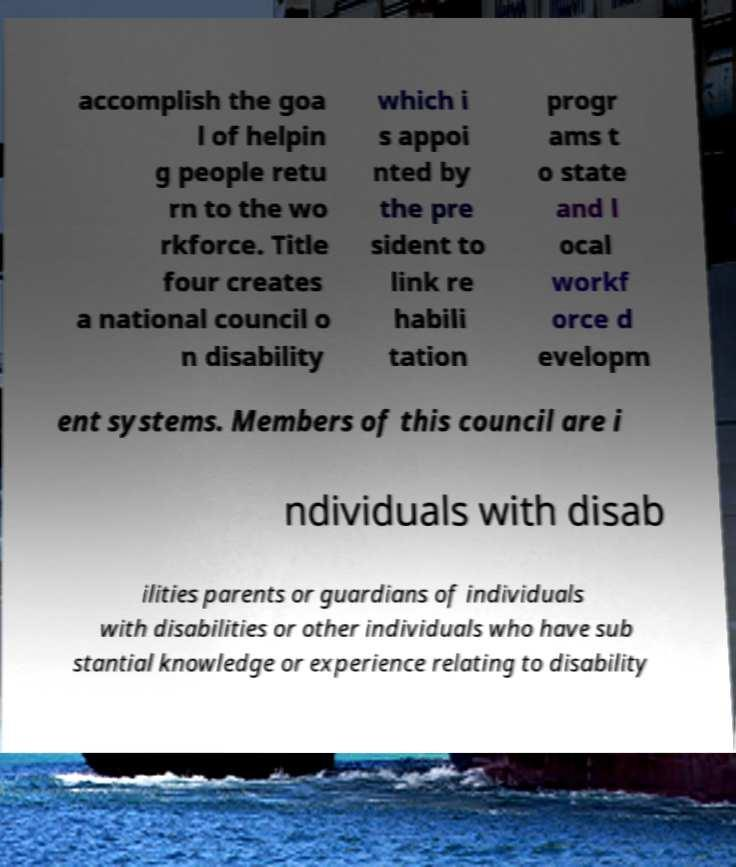Can you read and provide the text displayed in the image?This photo seems to have some interesting text. Can you extract and type it out for me? accomplish the goa l of helpin g people retu rn to the wo rkforce. Title four creates a national council o n disability which i s appoi nted by the pre sident to link re habili tation progr ams t o state and l ocal workf orce d evelopm ent systems. Members of this council are i ndividuals with disab ilities parents or guardians of individuals with disabilities or other individuals who have sub stantial knowledge or experience relating to disability 